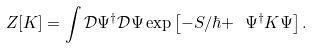<formula> <loc_0><loc_0><loc_500><loc_500>Z [ K ] = \int \mathcal { D } \Psi ^ { \dagger } \mathcal { D } \Psi \exp \left [ - S / \hbar { + } \ \Psi ^ { \dagger } K \Psi \right ] .</formula> 